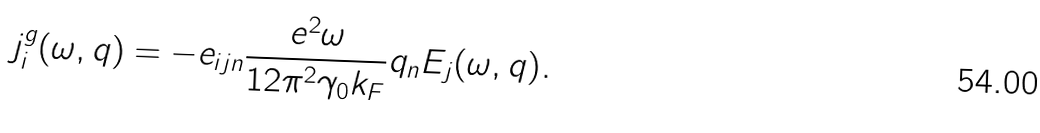Convert formula to latex. <formula><loc_0><loc_0><loc_500><loc_500>j ^ { g } _ { i } ( \omega , { q } ) = - e _ { i j n } \frac { e ^ { 2 } \omega } { 1 2 \pi ^ { 2 } \gamma _ { 0 } k _ { F } } q _ { n } { E _ { j } } ( \omega , { q } ) .</formula> 